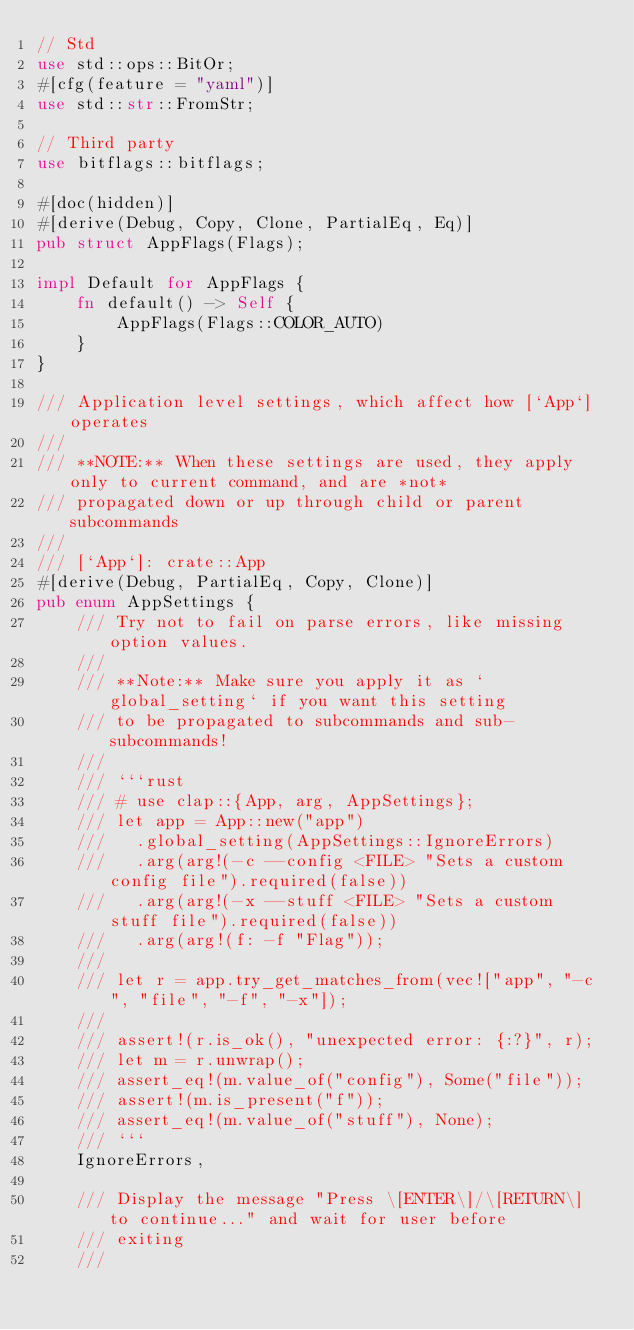<code> <loc_0><loc_0><loc_500><loc_500><_Rust_>// Std
use std::ops::BitOr;
#[cfg(feature = "yaml")]
use std::str::FromStr;

// Third party
use bitflags::bitflags;

#[doc(hidden)]
#[derive(Debug, Copy, Clone, PartialEq, Eq)]
pub struct AppFlags(Flags);

impl Default for AppFlags {
    fn default() -> Self {
        AppFlags(Flags::COLOR_AUTO)
    }
}

/// Application level settings, which affect how [`App`] operates
///
/// **NOTE:** When these settings are used, they apply only to current command, and are *not*
/// propagated down or up through child or parent subcommands
///
/// [`App`]: crate::App
#[derive(Debug, PartialEq, Copy, Clone)]
pub enum AppSettings {
    /// Try not to fail on parse errors, like missing option values.
    ///
    /// **Note:** Make sure you apply it as `global_setting` if you want this setting
    /// to be propagated to subcommands and sub-subcommands!
    ///
    /// ```rust
    /// # use clap::{App, arg, AppSettings};
    /// let app = App::new("app")
    ///   .global_setting(AppSettings::IgnoreErrors)
    ///   .arg(arg!(-c --config <FILE> "Sets a custom config file").required(false))
    ///   .arg(arg!(-x --stuff <FILE> "Sets a custom stuff file").required(false))
    ///   .arg(arg!(f: -f "Flag"));
    ///
    /// let r = app.try_get_matches_from(vec!["app", "-c", "file", "-f", "-x"]);
    ///
    /// assert!(r.is_ok(), "unexpected error: {:?}", r);
    /// let m = r.unwrap();
    /// assert_eq!(m.value_of("config"), Some("file"));
    /// assert!(m.is_present("f"));
    /// assert_eq!(m.value_of("stuff"), None);
    /// ```
    IgnoreErrors,

    /// Display the message "Press \[ENTER\]/\[RETURN\] to continue..." and wait for user before
    /// exiting
    ///</code> 